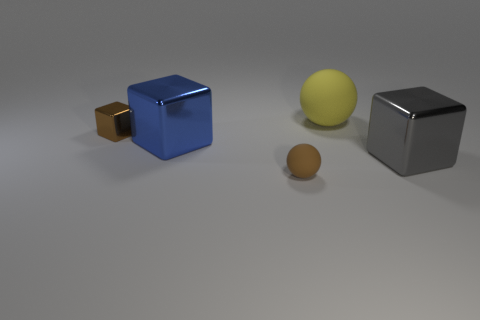How do the objects relate to each other in terms of size and spacing? The objects are positioned at varying distances from each other, creating a sense of depth in the arrangement. In terms of size, the small shiny object, which is a cube, is the smallest; the large silver cube is the largest; and the spherical objects are intermediate in size. There's a clear progression in scale that adds interest to the image composition. 